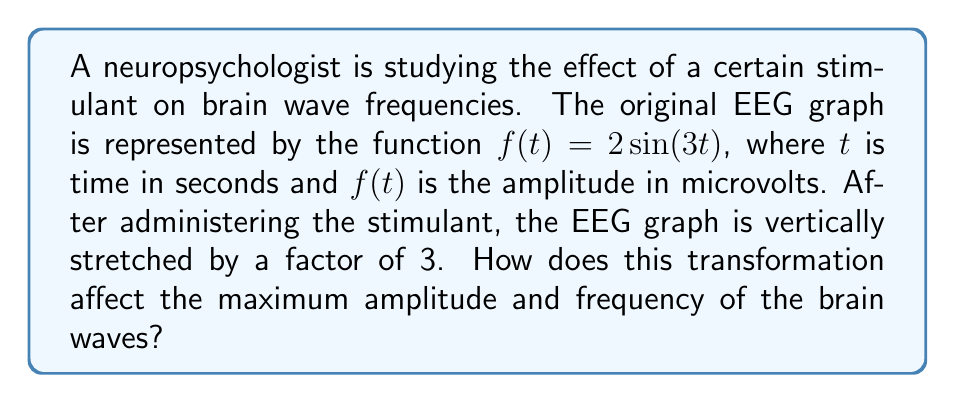Provide a solution to this math problem. 1. The original function is $f(t) = 2\sin(3t)$
   - Amplitude: 2 microvolts
   - Frequency: 3 Hz (angular frequency $\omega = 3$ rad/s)

2. The vertically stretched function is $g(t) = 3f(t) = 3(2\sin(3t)) = 6\sin(3t)$

3. Effect on amplitude:
   - New amplitude = 3 * original amplitude = 3 * 2 = 6 microvolts
   - The maximum amplitude has tripled

4. Effect on frequency:
   - The frequency is determined by the argument of the sine function (3t)
   - This remains unchanged in the transformed function
   - Therefore, the frequency stays the same at 3 Hz

5. In general, vertical stretching affects the amplitude of a sinusoidal function but does not change its frequency or period.
Answer: Maximum amplitude triples to 6 microvolts; frequency remains 3 Hz. 